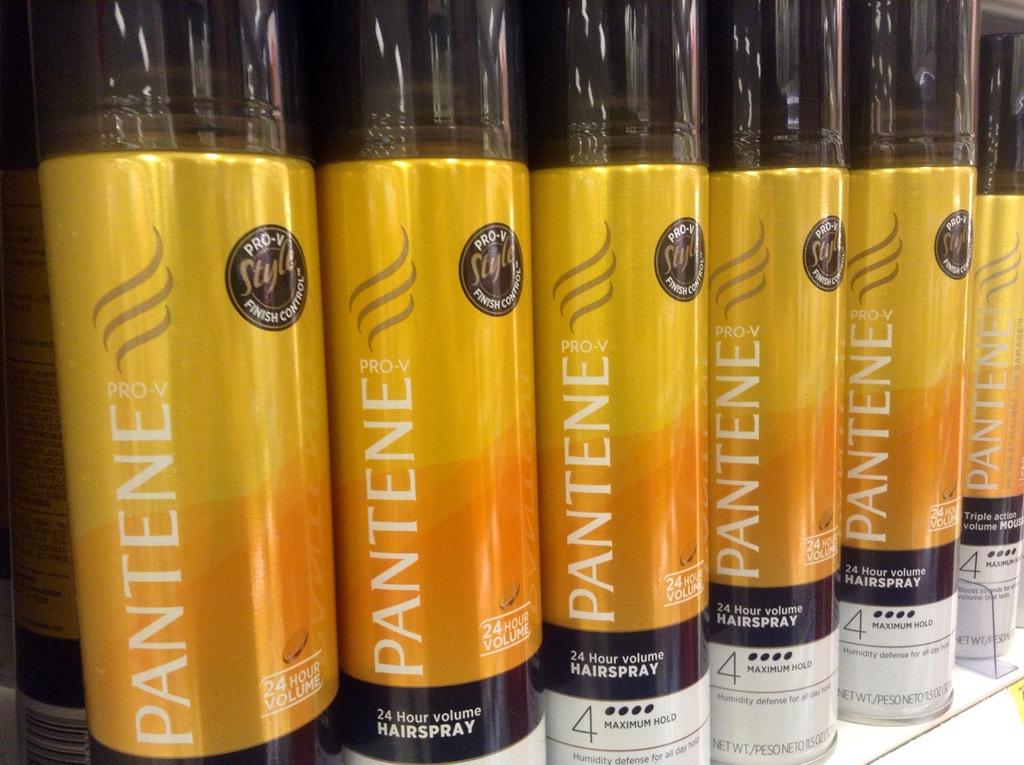What brand of hairspray is this?
Provide a short and direct response. Pantene. 